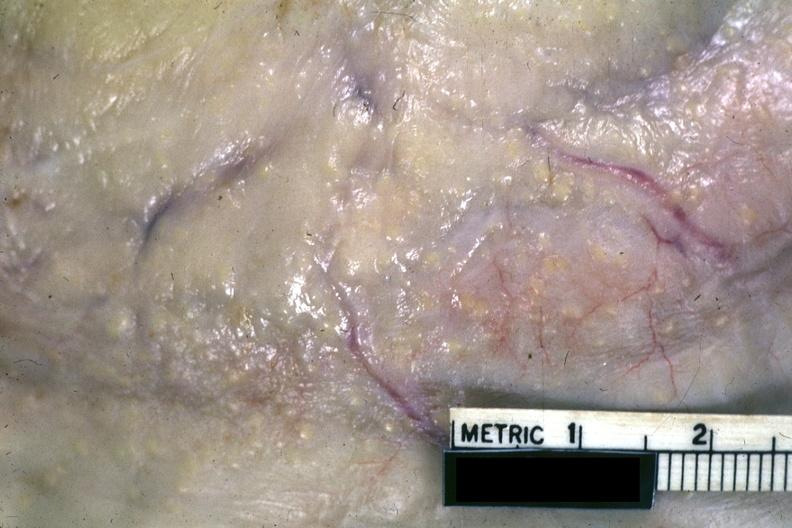s peritoneum present?
Answer the question using a single word or phrase. Yes 